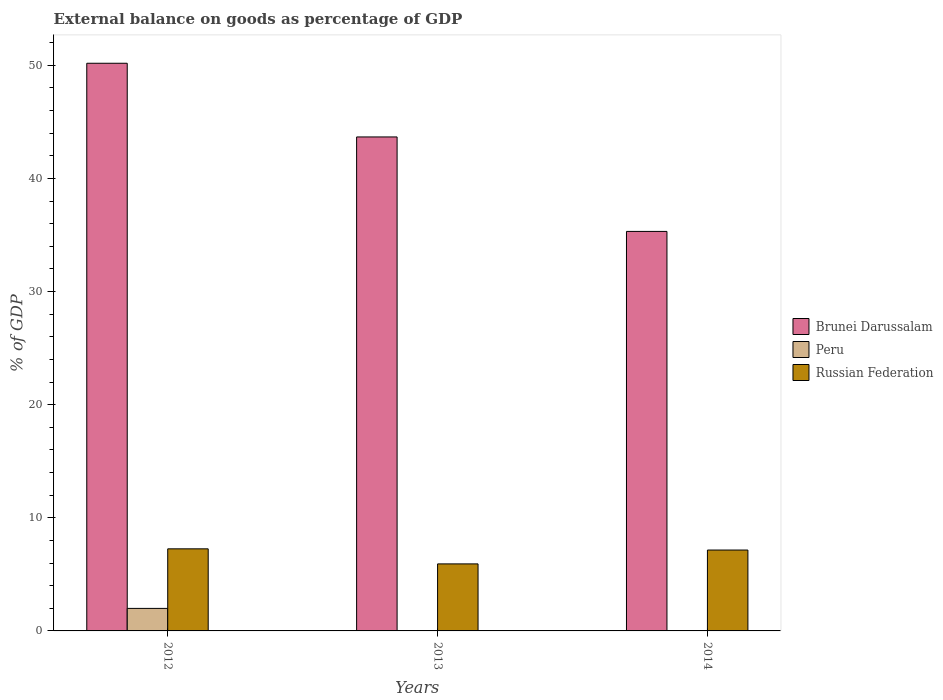Are the number of bars per tick equal to the number of legend labels?
Provide a short and direct response. No. How many bars are there on the 2nd tick from the left?
Provide a succinct answer. 2. How many bars are there on the 1st tick from the right?
Provide a succinct answer. 2. What is the label of the 3rd group of bars from the left?
Your answer should be very brief. 2014. What is the external balance on goods as percentage of GDP in Brunei Darussalam in 2013?
Make the answer very short. 43.67. Across all years, what is the maximum external balance on goods as percentage of GDP in Russian Federation?
Keep it short and to the point. 7.26. Across all years, what is the minimum external balance on goods as percentage of GDP in Brunei Darussalam?
Offer a terse response. 35.32. What is the total external balance on goods as percentage of GDP in Brunei Darussalam in the graph?
Make the answer very short. 129.18. What is the difference between the external balance on goods as percentage of GDP in Russian Federation in 2013 and that in 2014?
Offer a terse response. -1.22. What is the difference between the external balance on goods as percentage of GDP in Peru in 2012 and the external balance on goods as percentage of GDP in Russian Federation in 2013?
Provide a short and direct response. -3.93. What is the average external balance on goods as percentage of GDP in Brunei Darussalam per year?
Ensure brevity in your answer.  43.06. In the year 2012, what is the difference between the external balance on goods as percentage of GDP in Russian Federation and external balance on goods as percentage of GDP in Peru?
Provide a succinct answer. 5.27. What is the ratio of the external balance on goods as percentage of GDP in Russian Federation in 2012 to that in 2014?
Offer a terse response. 1.01. Is the external balance on goods as percentage of GDP in Brunei Darussalam in 2012 less than that in 2014?
Your response must be concise. No. What is the difference between the highest and the second highest external balance on goods as percentage of GDP in Brunei Darussalam?
Provide a succinct answer. 6.51. What is the difference between the highest and the lowest external balance on goods as percentage of GDP in Brunei Darussalam?
Provide a succinct answer. 14.87. Is the sum of the external balance on goods as percentage of GDP in Brunei Darussalam in 2012 and 2014 greater than the maximum external balance on goods as percentage of GDP in Peru across all years?
Your response must be concise. Yes. How many bars are there?
Give a very brief answer. 7. How many years are there in the graph?
Your answer should be compact. 3. What is the difference between two consecutive major ticks on the Y-axis?
Keep it short and to the point. 10. Where does the legend appear in the graph?
Your response must be concise. Center right. What is the title of the graph?
Offer a very short reply. External balance on goods as percentage of GDP. What is the label or title of the X-axis?
Give a very brief answer. Years. What is the label or title of the Y-axis?
Provide a short and direct response. % of GDP. What is the % of GDP of Brunei Darussalam in 2012?
Ensure brevity in your answer.  50.19. What is the % of GDP in Peru in 2012?
Ensure brevity in your answer.  1.99. What is the % of GDP of Russian Federation in 2012?
Your answer should be compact. 7.26. What is the % of GDP of Brunei Darussalam in 2013?
Make the answer very short. 43.67. What is the % of GDP of Peru in 2013?
Give a very brief answer. 0. What is the % of GDP in Russian Federation in 2013?
Provide a succinct answer. 5.93. What is the % of GDP of Brunei Darussalam in 2014?
Offer a terse response. 35.32. What is the % of GDP in Russian Federation in 2014?
Ensure brevity in your answer.  7.15. Across all years, what is the maximum % of GDP in Brunei Darussalam?
Your response must be concise. 50.19. Across all years, what is the maximum % of GDP in Peru?
Provide a succinct answer. 1.99. Across all years, what is the maximum % of GDP of Russian Federation?
Keep it short and to the point. 7.26. Across all years, what is the minimum % of GDP in Brunei Darussalam?
Keep it short and to the point. 35.32. Across all years, what is the minimum % of GDP in Russian Federation?
Keep it short and to the point. 5.93. What is the total % of GDP in Brunei Darussalam in the graph?
Give a very brief answer. 129.18. What is the total % of GDP in Peru in the graph?
Your answer should be compact. 1.99. What is the total % of GDP of Russian Federation in the graph?
Provide a short and direct response. 20.33. What is the difference between the % of GDP of Brunei Darussalam in 2012 and that in 2013?
Ensure brevity in your answer.  6.51. What is the difference between the % of GDP of Russian Federation in 2012 and that in 2013?
Provide a short and direct response. 1.33. What is the difference between the % of GDP in Brunei Darussalam in 2012 and that in 2014?
Keep it short and to the point. 14.87. What is the difference between the % of GDP in Russian Federation in 2012 and that in 2014?
Ensure brevity in your answer.  0.11. What is the difference between the % of GDP of Brunei Darussalam in 2013 and that in 2014?
Make the answer very short. 8.35. What is the difference between the % of GDP of Russian Federation in 2013 and that in 2014?
Provide a succinct answer. -1.22. What is the difference between the % of GDP of Brunei Darussalam in 2012 and the % of GDP of Russian Federation in 2013?
Ensure brevity in your answer.  44.26. What is the difference between the % of GDP in Peru in 2012 and the % of GDP in Russian Federation in 2013?
Give a very brief answer. -3.93. What is the difference between the % of GDP in Brunei Darussalam in 2012 and the % of GDP in Russian Federation in 2014?
Your response must be concise. 43.04. What is the difference between the % of GDP in Peru in 2012 and the % of GDP in Russian Federation in 2014?
Offer a terse response. -5.16. What is the difference between the % of GDP of Brunei Darussalam in 2013 and the % of GDP of Russian Federation in 2014?
Your response must be concise. 36.52. What is the average % of GDP in Brunei Darussalam per year?
Your answer should be compact. 43.06. What is the average % of GDP of Peru per year?
Your answer should be compact. 0.66. What is the average % of GDP of Russian Federation per year?
Give a very brief answer. 6.78. In the year 2012, what is the difference between the % of GDP of Brunei Darussalam and % of GDP of Peru?
Provide a short and direct response. 48.19. In the year 2012, what is the difference between the % of GDP of Brunei Darussalam and % of GDP of Russian Federation?
Give a very brief answer. 42.93. In the year 2012, what is the difference between the % of GDP of Peru and % of GDP of Russian Federation?
Your response must be concise. -5.27. In the year 2013, what is the difference between the % of GDP in Brunei Darussalam and % of GDP in Russian Federation?
Ensure brevity in your answer.  37.75. In the year 2014, what is the difference between the % of GDP in Brunei Darussalam and % of GDP in Russian Federation?
Provide a short and direct response. 28.17. What is the ratio of the % of GDP of Brunei Darussalam in 2012 to that in 2013?
Make the answer very short. 1.15. What is the ratio of the % of GDP of Russian Federation in 2012 to that in 2013?
Give a very brief answer. 1.22. What is the ratio of the % of GDP in Brunei Darussalam in 2012 to that in 2014?
Give a very brief answer. 1.42. What is the ratio of the % of GDP of Russian Federation in 2012 to that in 2014?
Provide a succinct answer. 1.01. What is the ratio of the % of GDP in Brunei Darussalam in 2013 to that in 2014?
Give a very brief answer. 1.24. What is the ratio of the % of GDP of Russian Federation in 2013 to that in 2014?
Your answer should be compact. 0.83. What is the difference between the highest and the second highest % of GDP in Brunei Darussalam?
Keep it short and to the point. 6.51. What is the difference between the highest and the second highest % of GDP in Russian Federation?
Make the answer very short. 0.11. What is the difference between the highest and the lowest % of GDP in Brunei Darussalam?
Make the answer very short. 14.87. What is the difference between the highest and the lowest % of GDP of Peru?
Keep it short and to the point. 1.99. What is the difference between the highest and the lowest % of GDP of Russian Federation?
Offer a terse response. 1.33. 